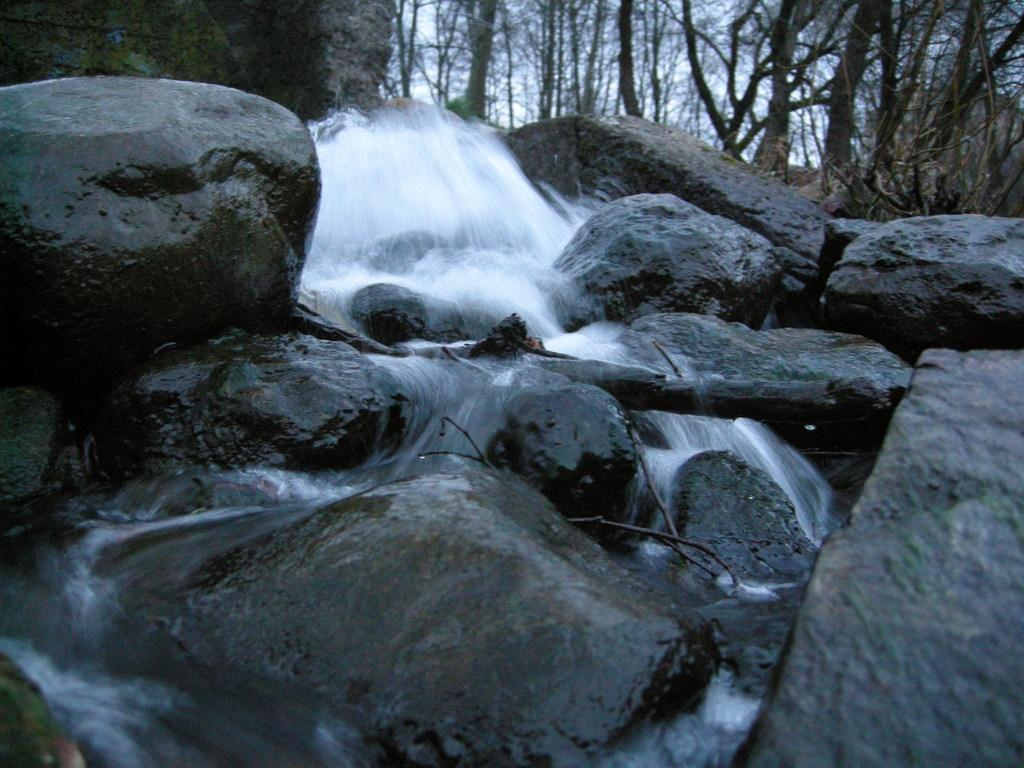What type of natural elements can be seen in the image? There are rocks, water, trees, and the sky visible in the image. Can you describe the water in the image? The water is visible in the image, but its specific characteristics are not mentioned. What type of vegetation is present in the image? There are trees in the image. What is visible in the background of the image? The sky is visible in the image. Is there a plate of food on the rocks in the image? There is no plate of food present in the image; it features rocks, water, trees, and the sky. Can you see a volcano erupting in the image? There is no volcano present in the image. 